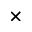Convert formula to latex. <formula><loc_0><loc_0><loc_500><loc_500>\times</formula> 